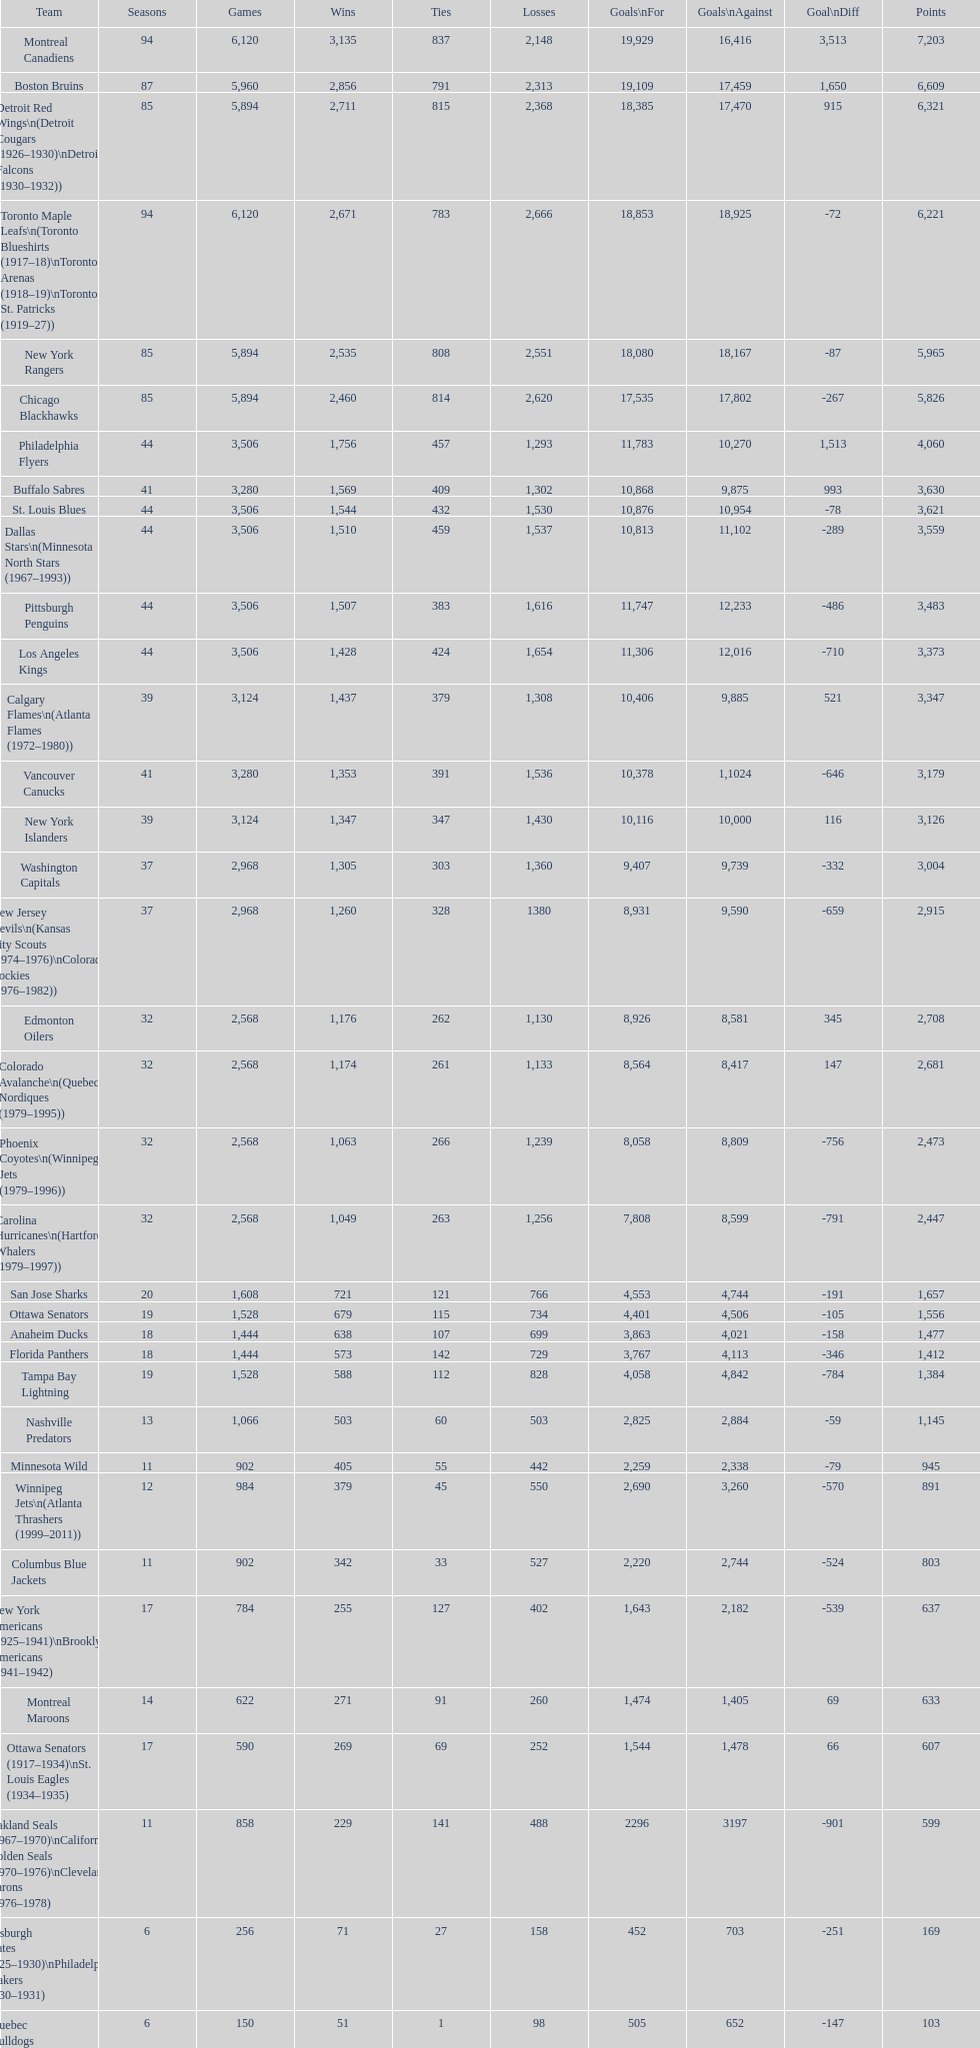Who has the least amount of losses? Montreal Wanderers. 